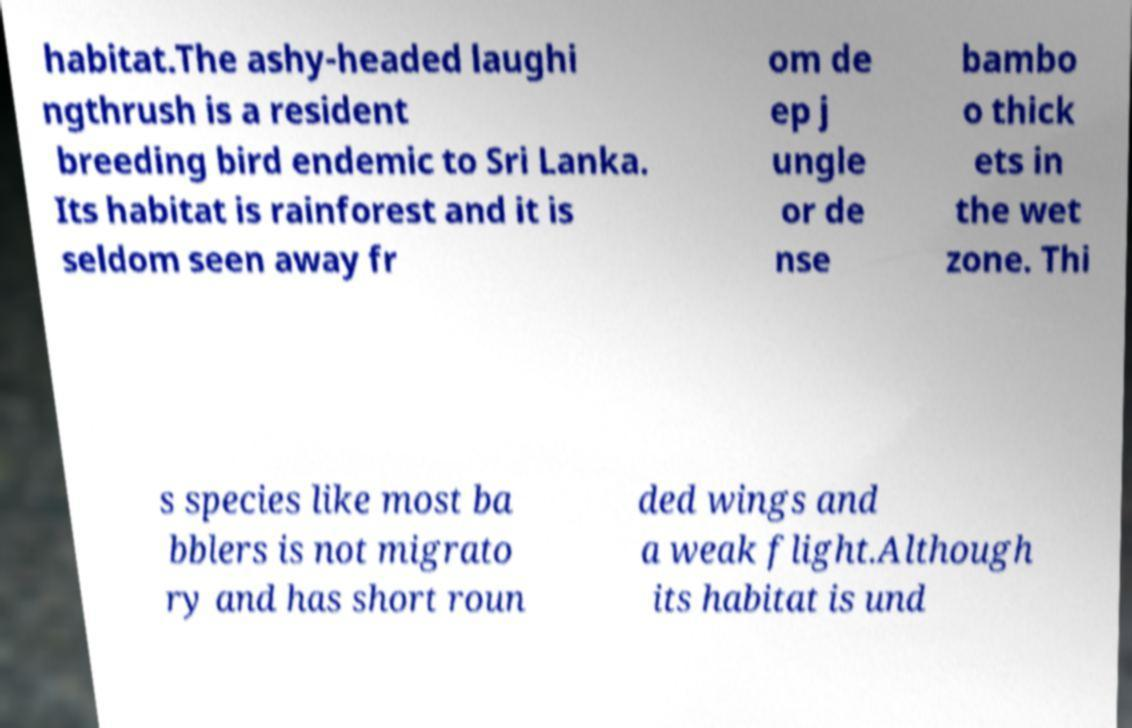Can you read and provide the text displayed in the image?This photo seems to have some interesting text. Can you extract and type it out for me? habitat.The ashy-headed laughi ngthrush is a resident breeding bird endemic to Sri Lanka. Its habitat is rainforest and it is seldom seen away fr om de ep j ungle or de nse bambo o thick ets in the wet zone. Thi s species like most ba bblers is not migrato ry and has short roun ded wings and a weak flight.Although its habitat is und 